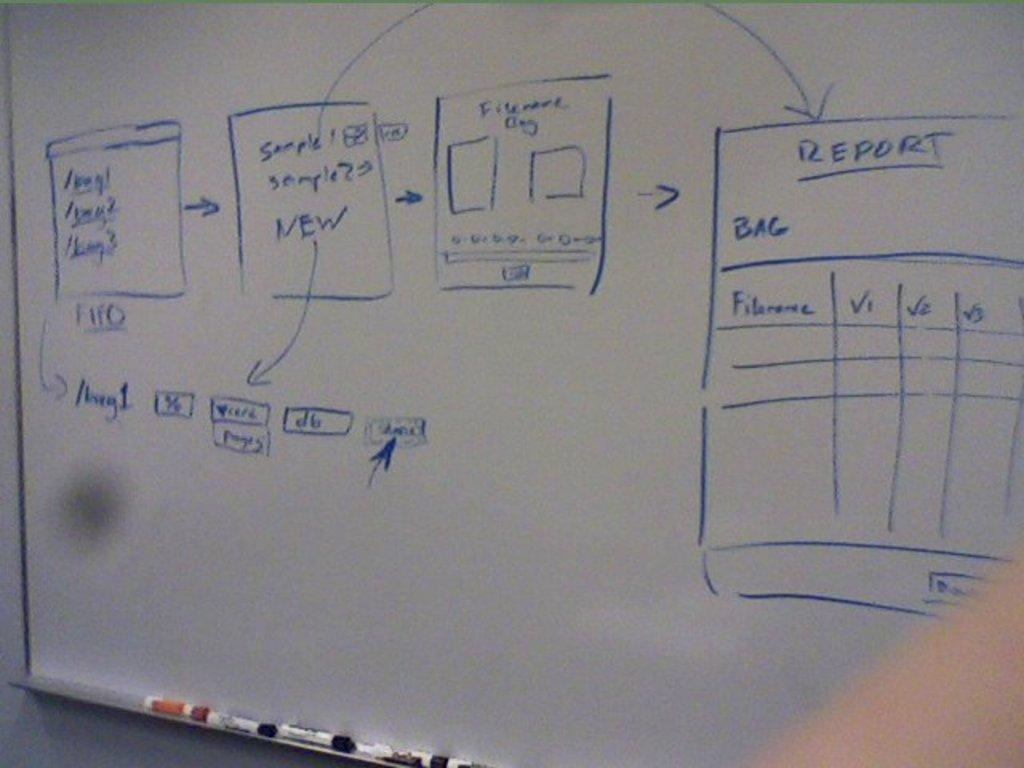<image>
Describe the image concisely. the word report that is written on a board 